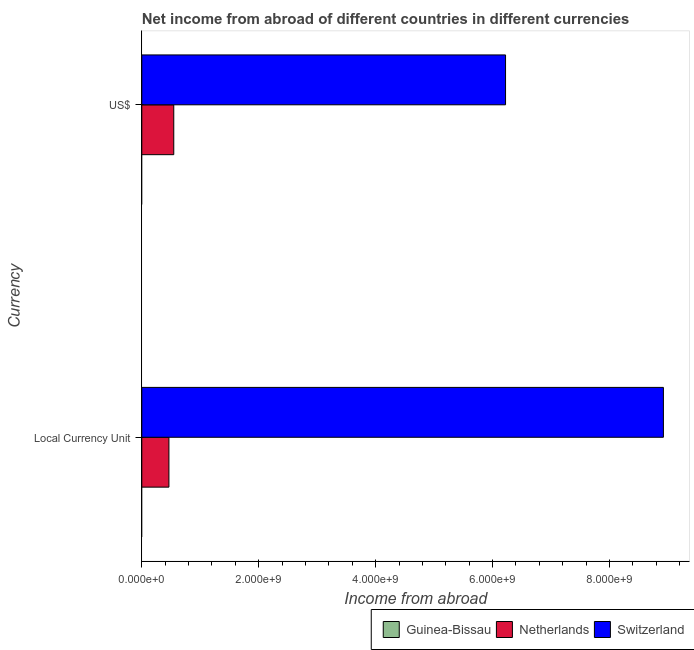How many groups of bars are there?
Give a very brief answer. 2. Are the number of bars per tick equal to the number of legend labels?
Offer a very short reply. No. Are the number of bars on each tick of the Y-axis equal?
Keep it short and to the point. Yes. How many bars are there on the 1st tick from the bottom?
Make the answer very short. 2. What is the label of the 2nd group of bars from the top?
Make the answer very short. Local Currency Unit. Across all countries, what is the maximum income from abroad in constant 2005 us$?
Your answer should be compact. 8.92e+09. Across all countries, what is the minimum income from abroad in us$?
Offer a very short reply. 0. In which country was the income from abroad in constant 2005 us$ maximum?
Give a very brief answer. Switzerland. What is the total income from abroad in constant 2005 us$ in the graph?
Offer a terse response. 9.39e+09. What is the difference between the income from abroad in us$ in Netherlands and that in Switzerland?
Make the answer very short. -5.68e+09. What is the difference between the income from abroad in us$ in Netherlands and the income from abroad in constant 2005 us$ in Switzerland?
Ensure brevity in your answer.  -8.38e+09. What is the average income from abroad in us$ per country?
Offer a terse response. 2.26e+09. What is the difference between the income from abroad in us$ and income from abroad in constant 2005 us$ in Netherlands?
Keep it short and to the point. 8.29e+07. In how many countries, is the income from abroad in constant 2005 us$ greater than 5600000000 units?
Offer a terse response. 1. What is the ratio of the income from abroad in constant 2005 us$ in Netherlands to that in Switzerland?
Keep it short and to the point. 0.05. Is the income from abroad in constant 2005 us$ in Switzerland less than that in Netherlands?
Give a very brief answer. No. In how many countries, is the income from abroad in us$ greater than the average income from abroad in us$ taken over all countries?
Offer a terse response. 1. Are all the bars in the graph horizontal?
Provide a succinct answer. Yes. How many countries are there in the graph?
Your answer should be compact. 3. What is the difference between two consecutive major ticks on the X-axis?
Provide a short and direct response. 2.00e+09. Are the values on the major ticks of X-axis written in scientific E-notation?
Keep it short and to the point. Yes. Does the graph contain any zero values?
Make the answer very short. Yes. Does the graph contain grids?
Offer a terse response. No. Where does the legend appear in the graph?
Keep it short and to the point. Bottom right. How many legend labels are there?
Provide a short and direct response. 3. How are the legend labels stacked?
Keep it short and to the point. Horizontal. What is the title of the graph?
Give a very brief answer. Net income from abroad of different countries in different currencies. Does "Costa Rica" appear as one of the legend labels in the graph?
Provide a short and direct response. No. What is the label or title of the X-axis?
Offer a terse response. Income from abroad. What is the label or title of the Y-axis?
Offer a terse response. Currency. What is the Income from abroad in Netherlands in Local Currency Unit?
Offer a very short reply. 4.64e+08. What is the Income from abroad in Switzerland in Local Currency Unit?
Keep it short and to the point. 8.92e+09. What is the Income from abroad in Guinea-Bissau in US$?
Provide a succinct answer. 0. What is the Income from abroad of Netherlands in US$?
Provide a succinct answer. 5.47e+08. What is the Income from abroad of Switzerland in US$?
Provide a short and direct response. 6.22e+09. Across all Currency, what is the maximum Income from abroad of Netherlands?
Ensure brevity in your answer.  5.47e+08. Across all Currency, what is the maximum Income from abroad in Switzerland?
Offer a very short reply. 8.92e+09. Across all Currency, what is the minimum Income from abroad of Netherlands?
Offer a very short reply. 4.64e+08. Across all Currency, what is the minimum Income from abroad in Switzerland?
Ensure brevity in your answer.  6.22e+09. What is the total Income from abroad in Guinea-Bissau in the graph?
Provide a short and direct response. 0. What is the total Income from abroad in Netherlands in the graph?
Keep it short and to the point. 1.01e+09. What is the total Income from abroad of Switzerland in the graph?
Your answer should be very brief. 1.51e+1. What is the difference between the Income from abroad in Netherlands in Local Currency Unit and that in US$?
Your answer should be very brief. -8.29e+07. What is the difference between the Income from abroad in Switzerland in Local Currency Unit and that in US$?
Your answer should be compact. 2.70e+09. What is the difference between the Income from abroad in Netherlands in Local Currency Unit and the Income from abroad in Switzerland in US$?
Give a very brief answer. -5.76e+09. What is the average Income from abroad of Guinea-Bissau per Currency?
Your answer should be compact. 0. What is the average Income from abroad in Netherlands per Currency?
Make the answer very short. 5.05e+08. What is the average Income from abroad in Switzerland per Currency?
Provide a short and direct response. 7.57e+09. What is the difference between the Income from abroad in Netherlands and Income from abroad in Switzerland in Local Currency Unit?
Give a very brief answer. -8.46e+09. What is the difference between the Income from abroad of Netherlands and Income from abroad of Switzerland in US$?
Your answer should be very brief. -5.68e+09. What is the ratio of the Income from abroad of Netherlands in Local Currency Unit to that in US$?
Give a very brief answer. 0.85. What is the ratio of the Income from abroad in Switzerland in Local Currency Unit to that in US$?
Offer a terse response. 1.43. What is the difference between the highest and the second highest Income from abroad of Netherlands?
Ensure brevity in your answer.  8.29e+07. What is the difference between the highest and the second highest Income from abroad in Switzerland?
Ensure brevity in your answer.  2.70e+09. What is the difference between the highest and the lowest Income from abroad in Netherlands?
Give a very brief answer. 8.29e+07. What is the difference between the highest and the lowest Income from abroad of Switzerland?
Make the answer very short. 2.70e+09. 